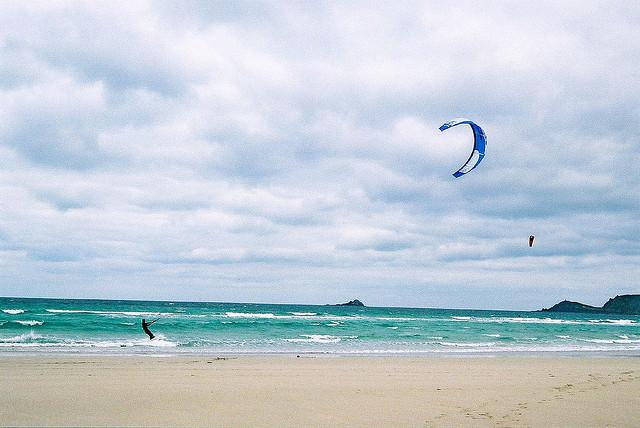What color are the eyes on the edges of the parasail pulling the skier?

Choices:
A) purple
B) red
C) pink
D) white white 